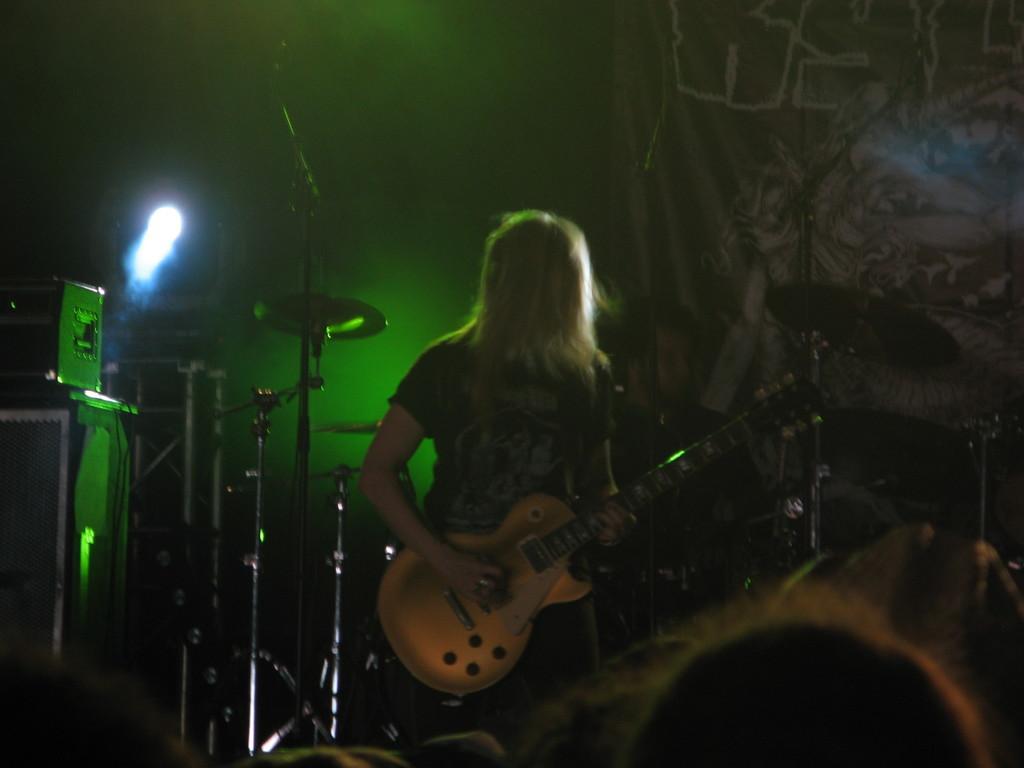Describe this image in one or two sentences. In this picture there is a person standing and hold guitar. On the background we can see a focusing light. There is drum plates and microphones with stands and there is musical instruments. 